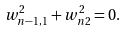<formula> <loc_0><loc_0><loc_500><loc_500>w _ { n - 1 , 1 } ^ { 2 } + w _ { n 2 } ^ { 2 } = 0 .</formula> 